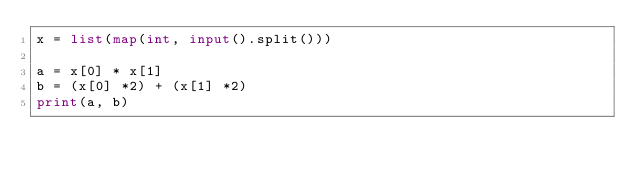Convert code to text. <code><loc_0><loc_0><loc_500><loc_500><_Python_>x = list(map(int, input().split()))

a = x[0] * x[1]
b = (x[0] *2) + (x[1] *2)
print(a, b)
</code> 